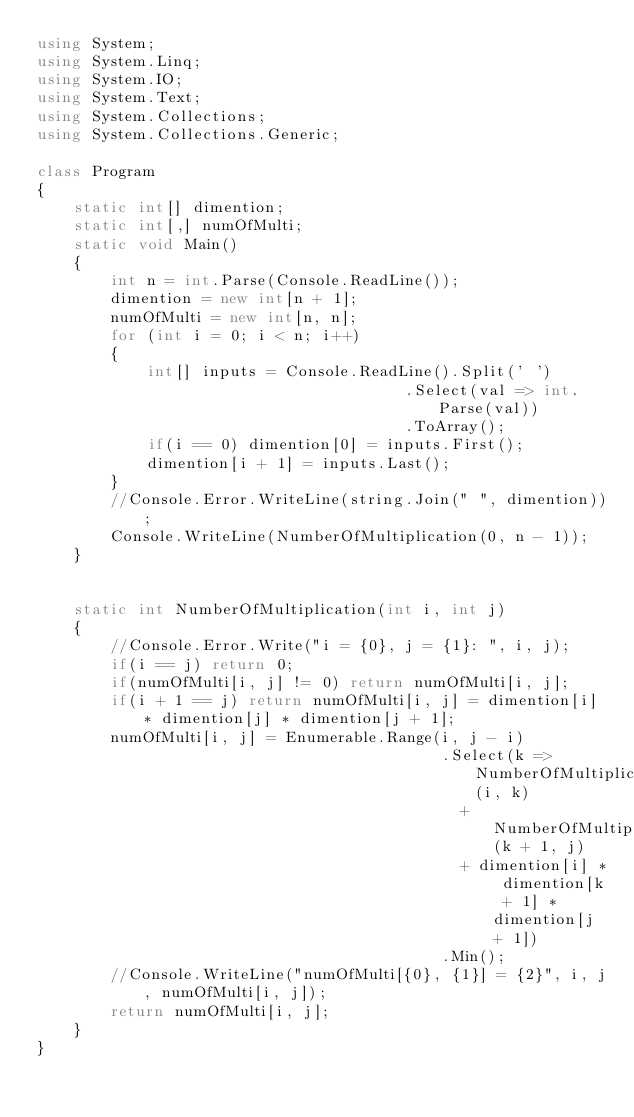Convert code to text. <code><loc_0><loc_0><loc_500><loc_500><_C#_>using System;
using System.Linq;
using System.IO;
using System.Text;
using System.Collections;
using System.Collections.Generic;
 
class Program
{
    static int[] dimention;
    static int[,] numOfMulti;
    static void Main()
    {
        int n = int.Parse(Console.ReadLine());
        dimention = new int[n + 1];
        numOfMulti = new int[n, n];
        for (int i = 0; i < n; i++)
        {
            int[] inputs = Console.ReadLine().Split(' ')
                                        .Select(val => int.Parse(val))
                                        .ToArray();
            if(i == 0) dimention[0] = inputs.First();
            dimention[i + 1] = inputs.Last();
        }
        //Console.Error.WriteLine(string.Join(" ", dimention));
        Console.WriteLine(NumberOfMultiplication(0, n - 1));
    }

    
    static int NumberOfMultiplication(int i, int j)
    {
        //Console.Error.Write("i = {0}, j = {1}: ", i, j);
        if(i == j) return 0;
        if(numOfMulti[i, j] != 0) return numOfMulti[i, j];
        if(i + 1 == j) return numOfMulti[i, j] = dimention[i] * dimention[j] * dimention[j + 1];
        numOfMulti[i, j] = Enumerable.Range(i, j - i)
                                            .Select(k => NumberOfMultiplication(i, k) 
                                              + NumberOfMultiplication(k + 1, j) 
                                              + dimention[i] * dimention[k + 1] * dimention[j + 1])
                                            .Min();
        //Console.WriteLine("numOfMulti[{0}, {1}] = {2}", i, j, numOfMulti[i, j]);
        return numOfMulti[i, j];
    }
}</code> 